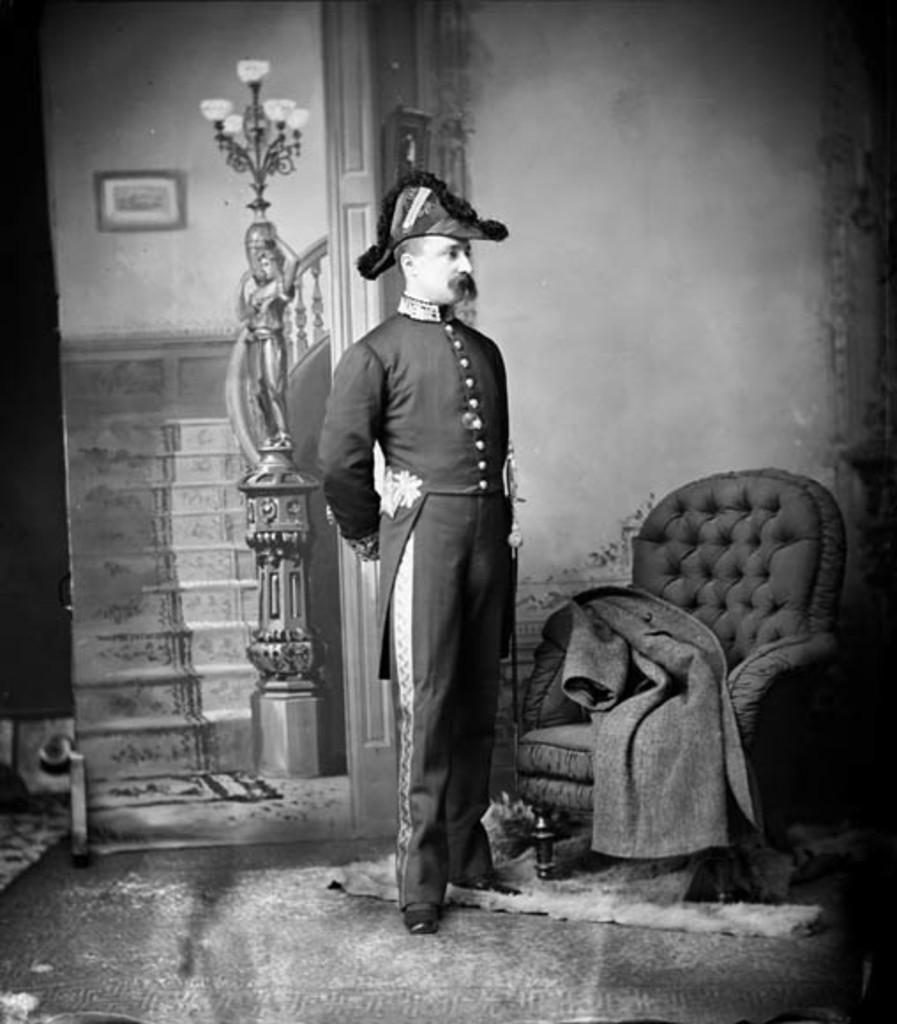What type of structure can be seen in the image? There is a wall in the image. What type of furniture is present in the image? There is a chair in the image. What is the person in the image doing? There is a person standing in the image. What type of art or decoration is present in the image? There is a statue in the image. What type of item is used for displaying photos or artwork in the image? There is a photo frame in the image. What type of architectural feature is present in the image? There are stairs in the image. What type of floor covering is present in the image? There are mats in the image. How does the person in the image stitch the sail on the boat? There is no boat or sail present in the image; it only features a wall, chair, person, statue, photo frame, stairs, and mats. 